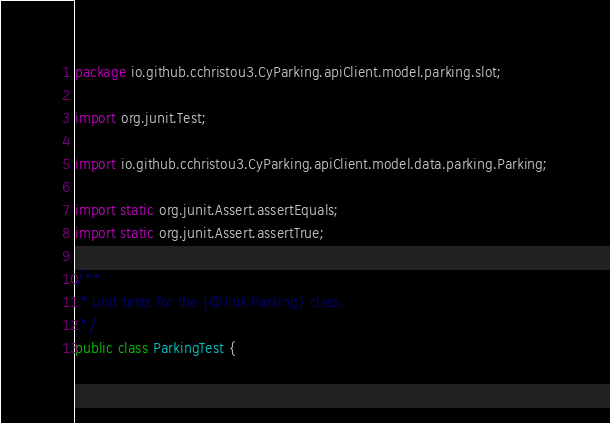<code> <loc_0><loc_0><loc_500><loc_500><_Java_>package io.github.cchristou3.CyParking.apiClient.model.parking.slot;

import org.junit.Test;

import io.github.cchristou3.CyParking.apiClient.model.data.parking.Parking;

import static org.junit.Assert.assertEquals;
import static org.junit.Assert.assertTrue;

/**
 * Unit tests for the {@link Parking} class.
 */
public class ParkingTest {
</code> 